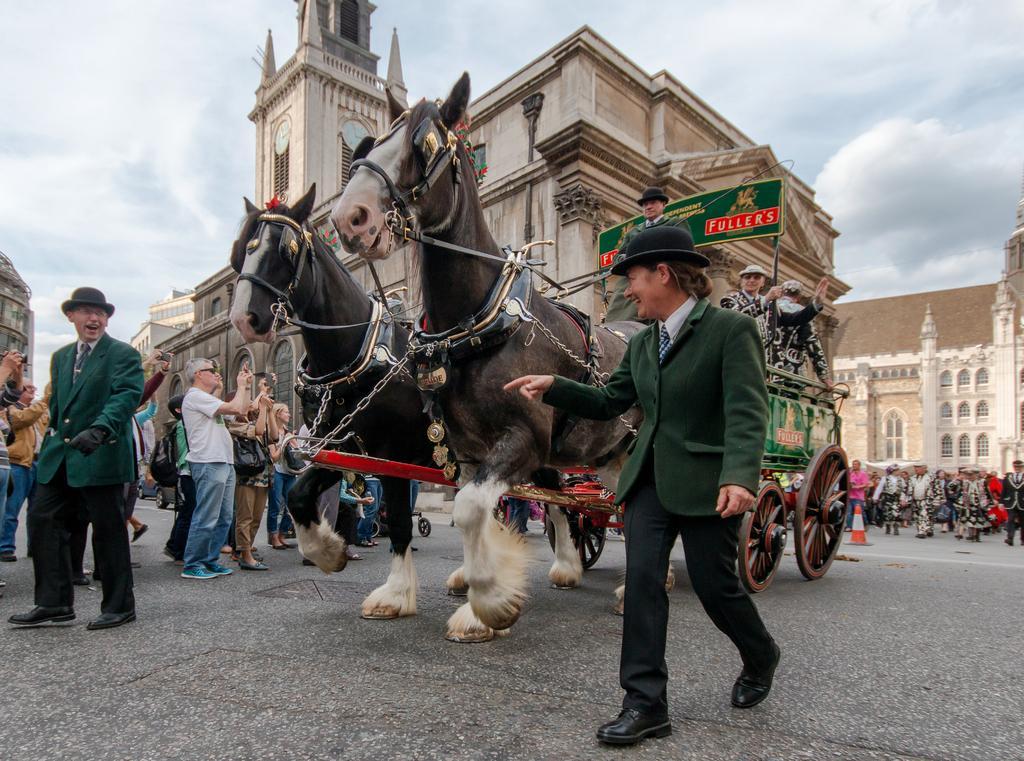How would you summarize this image in a sentence or two? In this image I can see two people wearing the green jacket and these people are walking to the side of Tanga. Inside the cart some people are standing. In the background there are group of people,building and the sky. 